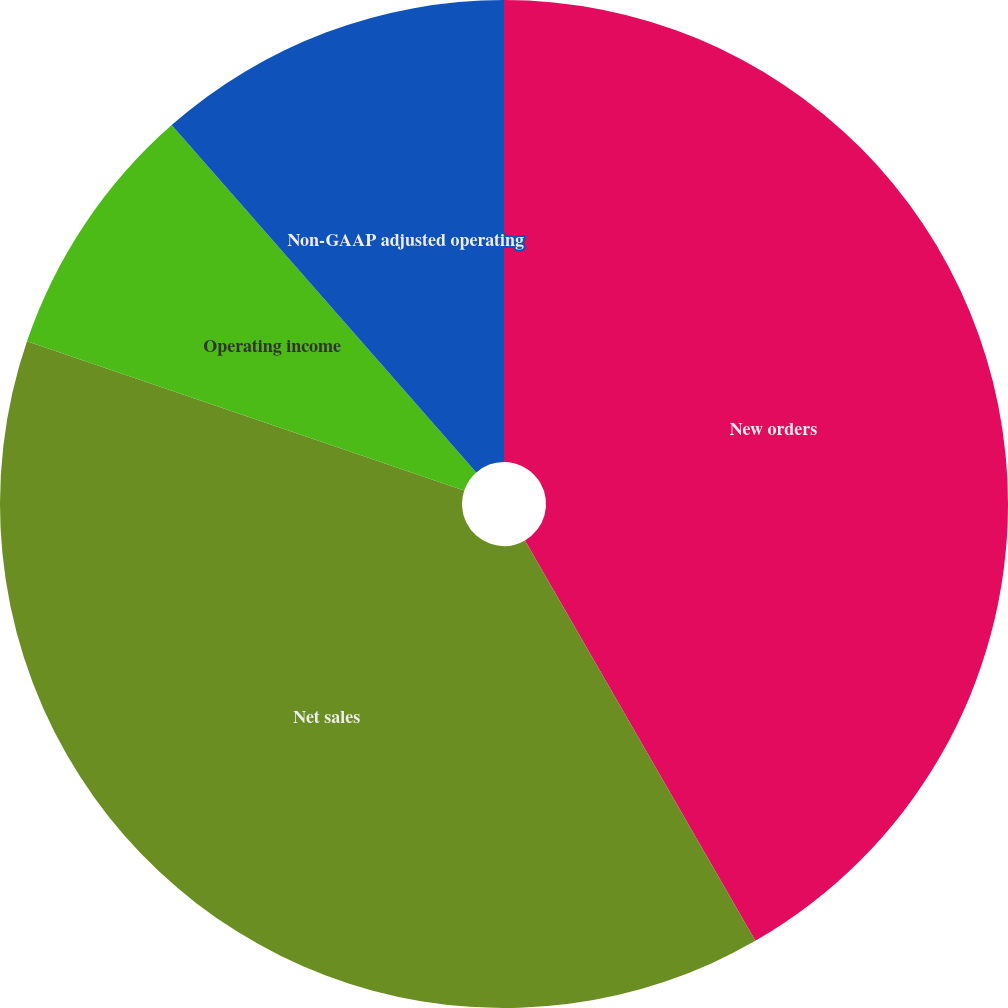Convert chart to OTSL. <chart><loc_0><loc_0><loc_500><loc_500><pie_chart><fcel>New orders<fcel>Net sales<fcel>Operating income<fcel>Non-GAAP adjusted operating<nl><fcel>41.69%<fcel>38.54%<fcel>8.31%<fcel>11.46%<nl></chart> 